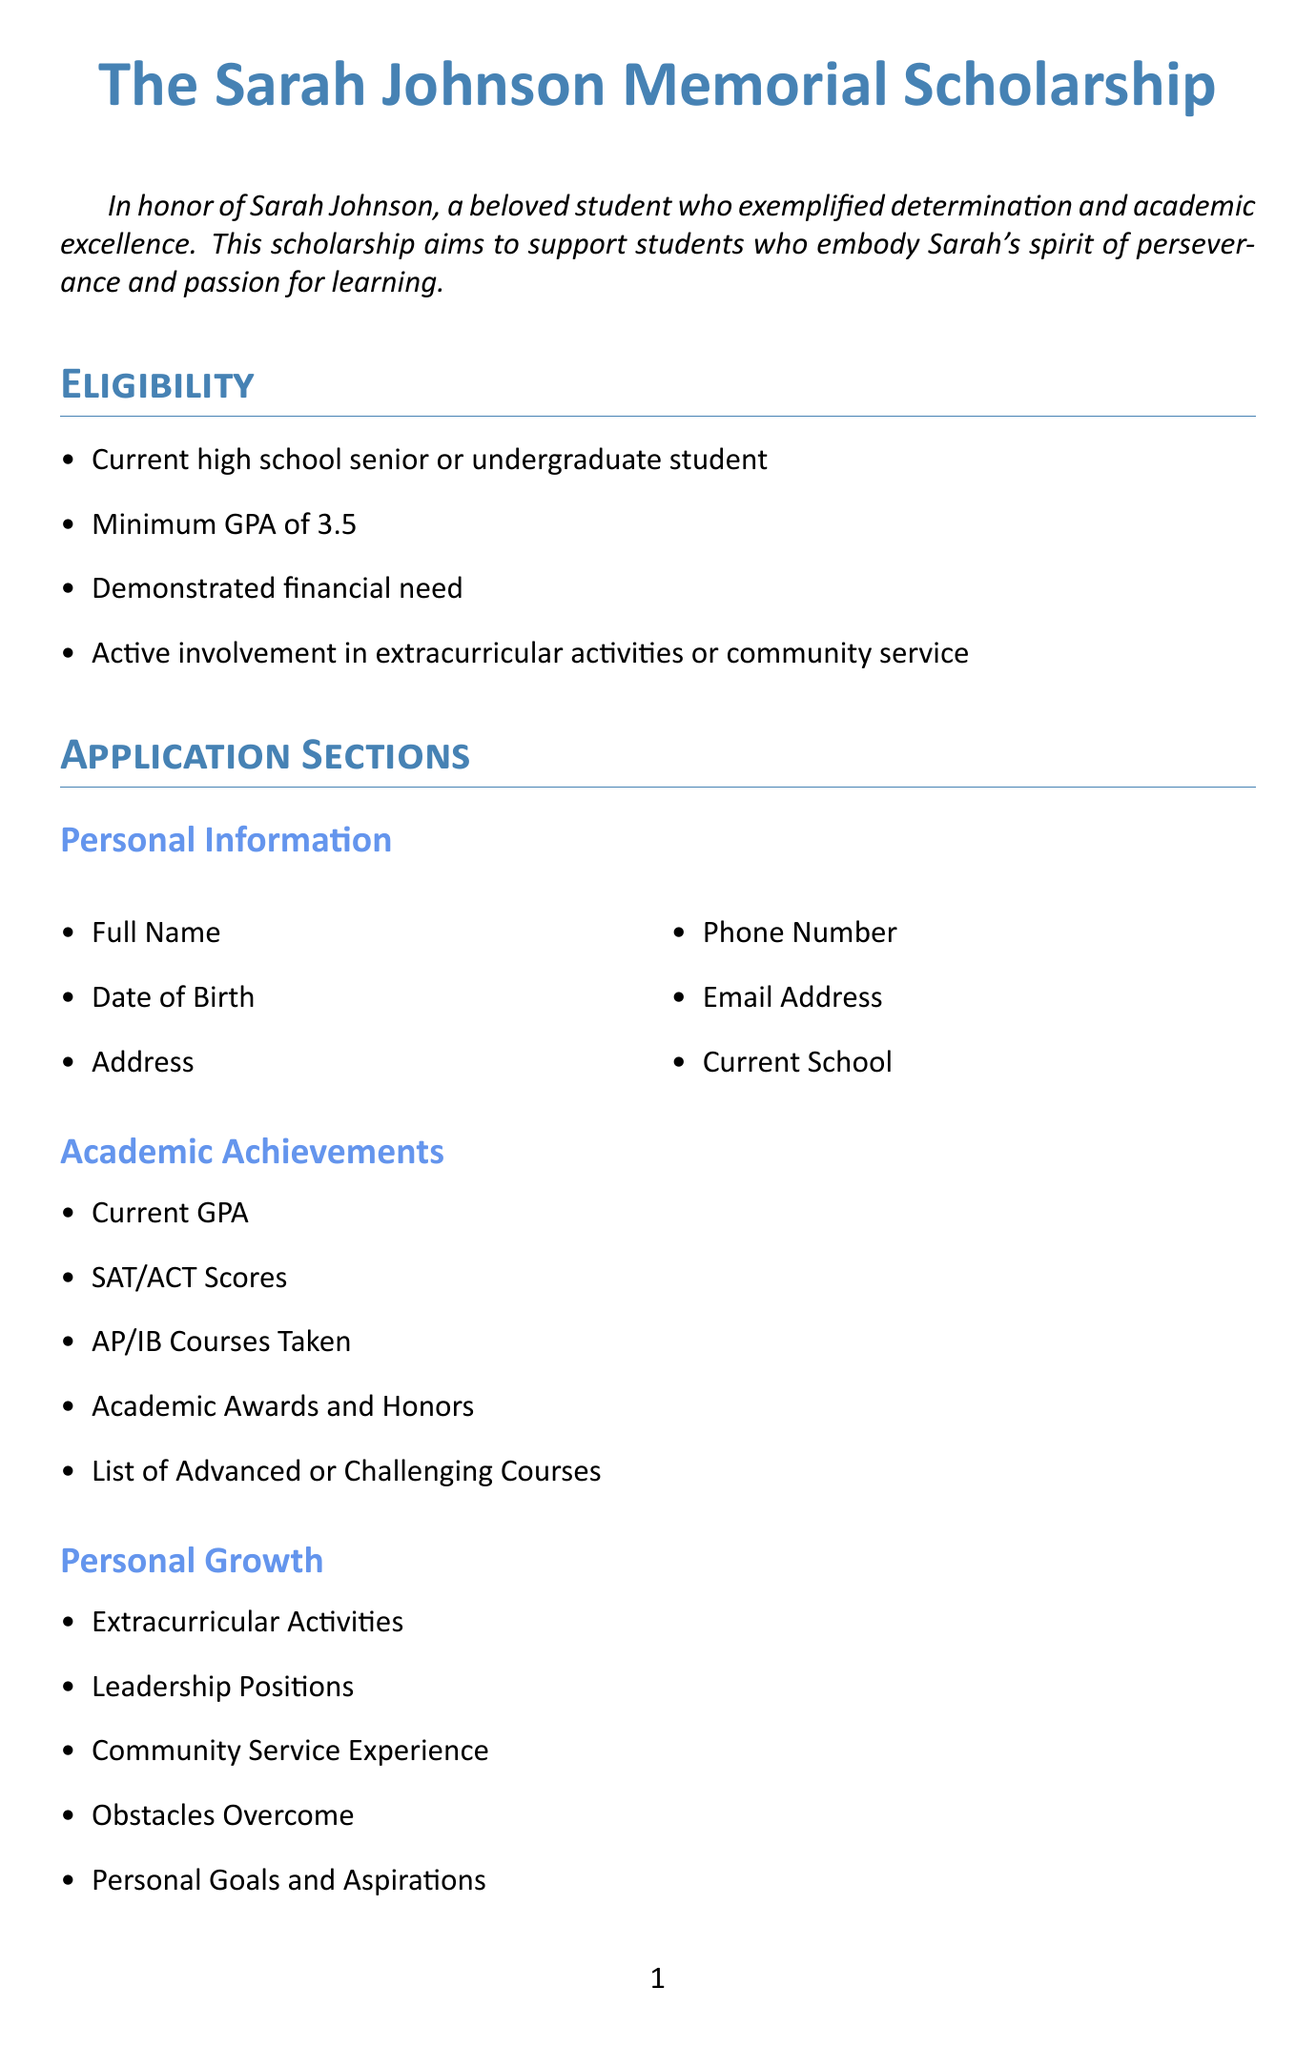what is the name of the scholarship? The name of the scholarship is mentioned at the beginning of the document.
Answer: The Sarah Johnson Memorial Scholarship who is the scholarship named in honor of? The scholarship is named in honor of a specific individual, as stated in the description.
Answer: Sarah Johnson what is the minimum GPA required for eligibility? The minimum GPA is outlined in the eligibility section of the document.
Answer: 3.5 how many letters of recommendation are required? The requirement for letters of recommendation is specified in the letters of recommendation subsection.
Answer: Two what is the deadline for submission? The submission deadline is clearly stated in the submission instructions section.
Answer: April 15, 2024 which section requires applicants to describe determination? One of the essay questions prompts applicants to discuss a specific experience related to determination.
Answer: Essay Questions name one selection criterion for the scholarship. The selection criteria are listed under a specific section in the document.
Answer: Academic excellence who is the founder of the scholarship? The founder is listed in the scholarship committee section of the document.
Answer: Mrs. Emily Thompson what is the submission method for the application? The submission method is described in the submission instructions part of the document.
Answer: Online portal at www.sarahjohnsonscholarship.org 